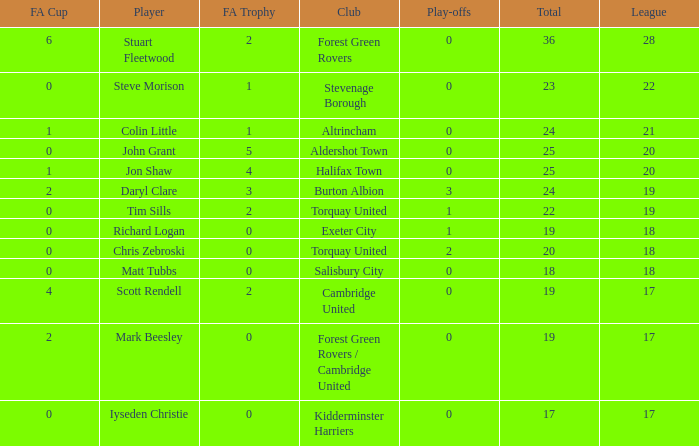Which mean total had Tim Sills as a player? 22.0. 